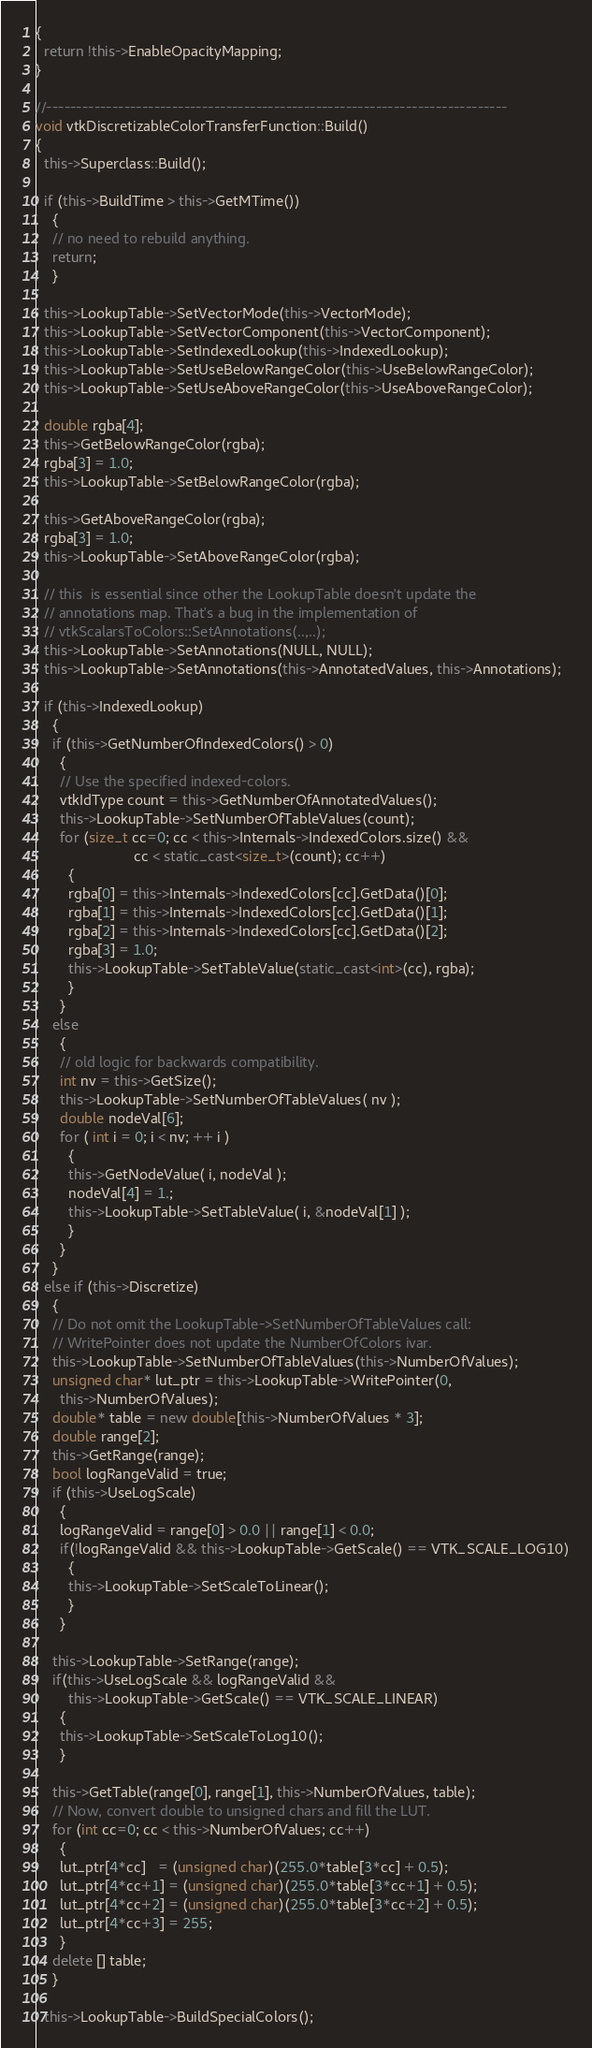<code> <loc_0><loc_0><loc_500><loc_500><_C++_>{
  return !this->EnableOpacityMapping;
}

//-----------------------------------------------------------------------------
void vtkDiscretizableColorTransferFunction::Build()
{
  this->Superclass::Build();

  if (this->BuildTime > this->GetMTime())
    {
    // no need to rebuild anything.
    return;
    }

  this->LookupTable->SetVectorMode(this->VectorMode);
  this->LookupTable->SetVectorComponent(this->VectorComponent);
  this->LookupTable->SetIndexedLookup(this->IndexedLookup);
  this->LookupTable->SetUseBelowRangeColor(this->UseBelowRangeColor);
  this->LookupTable->SetUseAboveRangeColor(this->UseAboveRangeColor);

  double rgba[4];
  this->GetBelowRangeColor(rgba);
  rgba[3] = 1.0;
  this->LookupTable->SetBelowRangeColor(rgba);

  this->GetAboveRangeColor(rgba);
  rgba[3] = 1.0;
  this->LookupTable->SetAboveRangeColor(rgba);

  // this  is essential since other the LookupTable doesn't update the
  // annotations map. That's a bug in the implementation of
  // vtkScalarsToColors::SetAnnotations(..,..);
  this->LookupTable->SetAnnotations(NULL, NULL);
  this->LookupTable->SetAnnotations(this->AnnotatedValues, this->Annotations);

  if (this->IndexedLookup)
    {
    if (this->GetNumberOfIndexedColors() > 0)
      {
      // Use the specified indexed-colors.
      vtkIdType count = this->GetNumberOfAnnotatedValues();
      this->LookupTable->SetNumberOfTableValues(count);
      for (size_t cc=0; cc < this->Internals->IndexedColors.size() &&
                        cc < static_cast<size_t>(count); cc++)
        {
        rgba[0] = this->Internals->IndexedColors[cc].GetData()[0];
        rgba[1] = this->Internals->IndexedColors[cc].GetData()[1];
        rgba[2] = this->Internals->IndexedColors[cc].GetData()[2];
        rgba[3] = 1.0;
        this->LookupTable->SetTableValue(static_cast<int>(cc), rgba);
        }
      }
    else
      {
      // old logic for backwards compatibility.
      int nv = this->GetSize();
      this->LookupTable->SetNumberOfTableValues( nv );
      double nodeVal[6];
      for ( int i = 0; i < nv; ++ i )
        {
        this->GetNodeValue( i, nodeVal );
        nodeVal[4] = 1.;
        this->LookupTable->SetTableValue( i, &nodeVal[1] );
        }
      }
    }
  else if (this->Discretize)
    {
    // Do not omit the LookupTable->SetNumberOfTableValues call:
    // WritePointer does not update the NumberOfColors ivar.
    this->LookupTable->SetNumberOfTableValues(this->NumberOfValues);
    unsigned char* lut_ptr = this->LookupTable->WritePointer(0,
      this->NumberOfValues);
    double* table = new double[this->NumberOfValues * 3];
    double range[2];
    this->GetRange(range);
    bool logRangeValid = true;
    if (this->UseLogScale)
      {
      logRangeValid = range[0] > 0.0 || range[1] < 0.0;
      if(!logRangeValid && this->LookupTable->GetScale() == VTK_SCALE_LOG10)
        {
        this->LookupTable->SetScaleToLinear();
        }
      }

    this->LookupTable->SetRange(range);
    if(this->UseLogScale && logRangeValid &&
        this->LookupTable->GetScale() == VTK_SCALE_LINEAR)
      {
      this->LookupTable->SetScaleToLog10();
      }

    this->GetTable(range[0], range[1], this->NumberOfValues, table);
    // Now, convert double to unsigned chars and fill the LUT.
    for (int cc=0; cc < this->NumberOfValues; cc++)
      {
      lut_ptr[4*cc]   = (unsigned char)(255.0*table[3*cc] + 0.5);
      lut_ptr[4*cc+1] = (unsigned char)(255.0*table[3*cc+1] + 0.5);
      lut_ptr[4*cc+2] = (unsigned char)(255.0*table[3*cc+2] + 0.5);
      lut_ptr[4*cc+3] = 255;
      }
    delete [] table;
    }

  this->LookupTable->BuildSpecialColors();
</code> 